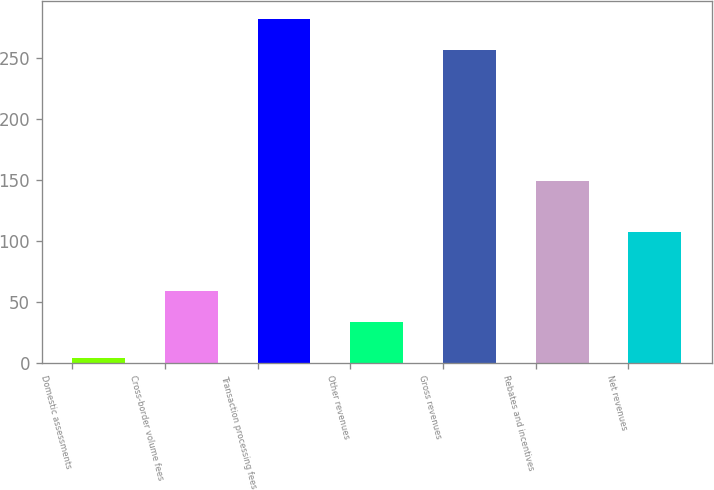Convert chart. <chart><loc_0><loc_0><loc_500><loc_500><bar_chart><fcel>Domestic assessments<fcel>Cross-border volume fees<fcel>Transaction processing fees<fcel>Other revenues<fcel>Gross revenues<fcel>Rebates and incentives<fcel>Net revenues<nl><fcel>4<fcel>59.1<fcel>282.1<fcel>33<fcel>256<fcel>149<fcel>107<nl></chart> 